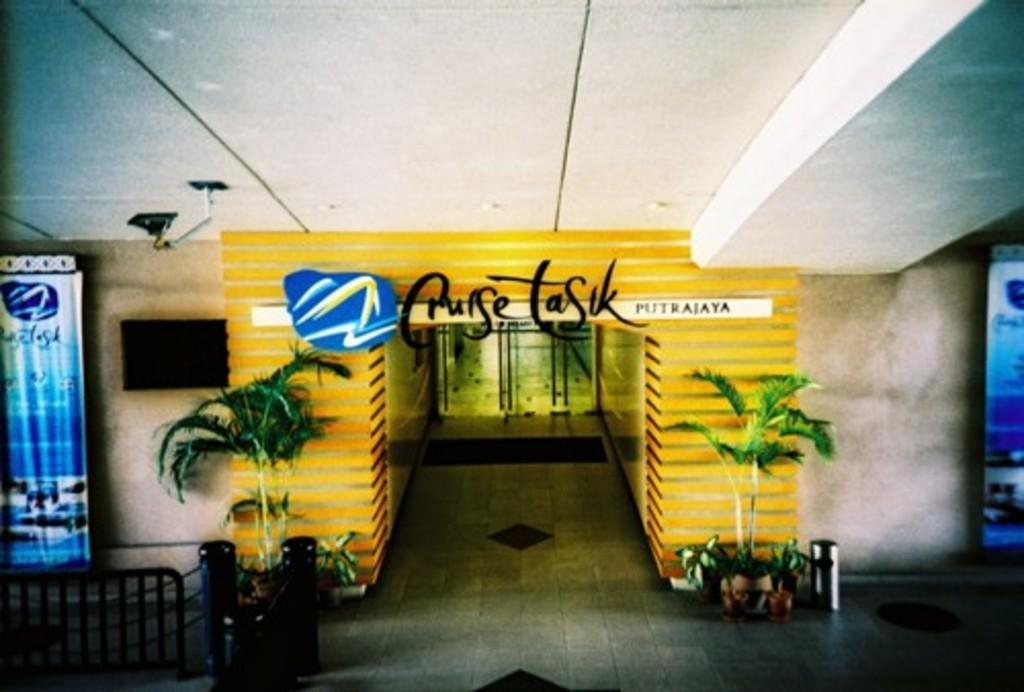<image>
Present a compact description of the photo's key features. A Cruise Tasik Putrajaya sign is displayed over an entrance. 